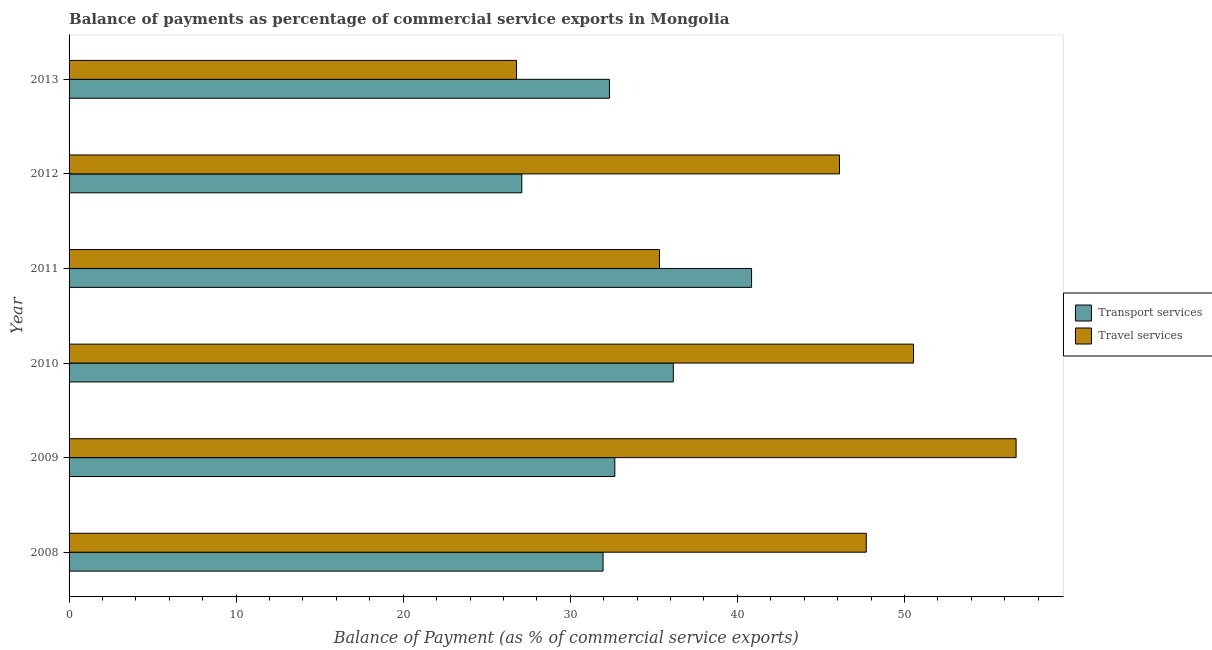Are the number of bars per tick equal to the number of legend labels?
Give a very brief answer. Yes. How many bars are there on the 3rd tick from the top?
Your response must be concise. 2. How many bars are there on the 6th tick from the bottom?
Your answer should be very brief. 2. What is the label of the 3rd group of bars from the top?
Your answer should be very brief. 2011. In how many cases, is the number of bars for a given year not equal to the number of legend labels?
Your answer should be compact. 0. What is the balance of payments of travel services in 2009?
Your answer should be compact. 56.68. Across all years, what is the maximum balance of payments of transport services?
Your answer should be very brief. 40.85. Across all years, what is the minimum balance of payments of travel services?
Make the answer very short. 26.78. In which year was the balance of payments of travel services maximum?
Your answer should be compact. 2009. In which year was the balance of payments of travel services minimum?
Offer a terse response. 2013. What is the total balance of payments of travel services in the graph?
Provide a succinct answer. 263.18. What is the difference between the balance of payments of transport services in 2010 and that in 2013?
Provide a short and direct response. 3.83. What is the difference between the balance of payments of travel services in 2008 and the balance of payments of transport services in 2009?
Give a very brief answer. 15.05. What is the average balance of payments of travel services per year?
Offer a terse response. 43.86. In the year 2012, what is the difference between the balance of payments of travel services and balance of payments of transport services?
Give a very brief answer. 19.02. What is the ratio of the balance of payments of travel services in 2010 to that in 2012?
Offer a very short reply. 1.1. Is the difference between the balance of payments of transport services in 2012 and 2013 greater than the difference between the balance of payments of travel services in 2012 and 2013?
Your answer should be compact. No. What is the difference between the highest and the second highest balance of payments of transport services?
Your answer should be compact. 4.68. What is the difference between the highest and the lowest balance of payments of travel services?
Make the answer very short. 29.9. In how many years, is the balance of payments of travel services greater than the average balance of payments of travel services taken over all years?
Ensure brevity in your answer.  4. What does the 2nd bar from the top in 2011 represents?
Your answer should be compact. Transport services. What does the 2nd bar from the bottom in 2013 represents?
Offer a very short reply. Travel services. Are all the bars in the graph horizontal?
Give a very brief answer. Yes. How many years are there in the graph?
Ensure brevity in your answer.  6. Does the graph contain any zero values?
Offer a very short reply. No. Where does the legend appear in the graph?
Make the answer very short. Center right. What is the title of the graph?
Keep it short and to the point. Balance of payments as percentage of commercial service exports in Mongolia. What is the label or title of the X-axis?
Offer a terse response. Balance of Payment (as % of commercial service exports). What is the Balance of Payment (as % of commercial service exports) in Transport services in 2008?
Provide a succinct answer. 31.96. What is the Balance of Payment (as % of commercial service exports) of Travel services in 2008?
Your answer should be very brief. 47.72. What is the Balance of Payment (as % of commercial service exports) in Transport services in 2009?
Provide a short and direct response. 32.67. What is the Balance of Payment (as % of commercial service exports) in Travel services in 2009?
Your response must be concise. 56.68. What is the Balance of Payment (as % of commercial service exports) of Transport services in 2010?
Your response must be concise. 36.17. What is the Balance of Payment (as % of commercial service exports) of Travel services in 2010?
Make the answer very short. 50.55. What is the Balance of Payment (as % of commercial service exports) in Transport services in 2011?
Ensure brevity in your answer.  40.85. What is the Balance of Payment (as % of commercial service exports) of Travel services in 2011?
Give a very brief answer. 35.34. What is the Balance of Payment (as % of commercial service exports) of Transport services in 2012?
Your answer should be very brief. 27.1. What is the Balance of Payment (as % of commercial service exports) in Travel services in 2012?
Offer a terse response. 46.11. What is the Balance of Payment (as % of commercial service exports) of Transport services in 2013?
Give a very brief answer. 32.34. What is the Balance of Payment (as % of commercial service exports) of Travel services in 2013?
Offer a terse response. 26.78. Across all years, what is the maximum Balance of Payment (as % of commercial service exports) in Transport services?
Provide a succinct answer. 40.85. Across all years, what is the maximum Balance of Payment (as % of commercial service exports) of Travel services?
Keep it short and to the point. 56.68. Across all years, what is the minimum Balance of Payment (as % of commercial service exports) in Transport services?
Your response must be concise. 27.1. Across all years, what is the minimum Balance of Payment (as % of commercial service exports) of Travel services?
Give a very brief answer. 26.78. What is the total Balance of Payment (as % of commercial service exports) of Transport services in the graph?
Ensure brevity in your answer.  201.09. What is the total Balance of Payment (as % of commercial service exports) in Travel services in the graph?
Your response must be concise. 263.18. What is the difference between the Balance of Payment (as % of commercial service exports) in Transport services in 2008 and that in 2009?
Your response must be concise. -0.7. What is the difference between the Balance of Payment (as % of commercial service exports) in Travel services in 2008 and that in 2009?
Make the answer very short. -8.97. What is the difference between the Balance of Payment (as % of commercial service exports) in Transport services in 2008 and that in 2010?
Keep it short and to the point. -4.21. What is the difference between the Balance of Payment (as % of commercial service exports) of Travel services in 2008 and that in 2010?
Offer a terse response. -2.83. What is the difference between the Balance of Payment (as % of commercial service exports) in Transport services in 2008 and that in 2011?
Provide a short and direct response. -8.89. What is the difference between the Balance of Payment (as % of commercial service exports) of Travel services in 2008 and that in 2011?
Provide a short and direct response. 12.38. What is the difference between the Balance of Payment (as % of commercial service exports) in Transport services in 2008 and that in 2012?
Make the answer very short. 4.86. What is the difference between the Balance of Payment (as % of commercial service exports) in Travel services in 2008 and that in 2012?
Make the answer very short. 1.6. What is the difference between the Balance of Payment (as % of commercial service exports) in Transport services in 2008 and that in 2013?
Your answer should be compact. -0.38. What is the difference between the Balance of Payment (as % of commercial service exports) of Travel services in 2008 and that in 2013?
Your answer should be compact. 20.93. What is the difference between the Balance of Payment (as % of commercial service exports) of Transport services in 2009 and that in 2010?
Ensure brevity in your answer.  -3.5. What is the difference between the Balance of Payment (as % of commercial service exports) in Travel services in 2009 and that in 2010?
Keep it short and to the point. 6.14. What is the difference between the Balance of Payment (as % of commercial service exports) of Transport services in 2009 and that in 2011?
Provide a short and direct response. -8.19. What is the difference between the Balance of Payment (as % of commercial service exports) of Travel services in 2009 and that in 2011?
Offer a very short reply. 21.35. What is the difference between the Balance of Payment (as % of commercial service exports) in Transport services in 2009 and that in 2012?
Keep it short and to the point. 5.57. What is the difference between the Balance of Payment (as % of commercial service exports) in Travel services in 2009 and that in 2012?
Your answer should be very brief. 10.57. What is the difference between the Balance of Payment (as % of commercial service exports) in Transport services in 2009 and that in 2013?
Provide a succinct answer. 0.32. What is the difference between the Balance of Payment (as % of commercial service exports) in Travel services in 2009 and that in 2013?
Keep it short and to the point. 29.9. What is the difference between the Balance of Payment (as % of commercial service exports) in Transport services in 2010 and that in 2011?
Offer a very short reply. -4.68. What is the difference between the Balance of Payment (as % of commercial service exports) in Travel services in 2010 and that in 2011?
Provide a short and direct response. 15.21. What is the difference between the Balance of Payment (as % of commercial service exports) in Transport services in 2010 and that in 2012?
Make the answer very short. 9.07. What is the difference between the Balance of Payment (as % of commercial service exports) in Travel services in 2010 and that in 2012?
Provide a succinct answer. 4.43. What is the difference between the Balance of Payment (as % of commercial service exports) in Transport services in 2010 and that in 2013?
Give a very brief answer. 3.83. What is the difference between the Balance of Payment (as % of commercial service exports) of Travel services in 2010 and that in 2013?
Keep it short and to the point. 23.76. What is the difference between the Balance of Payment (as % of commercial service exports) in Transport services in 2011 and that in 2012?
Give a very brief answer. 13.75. What is the difference between the Balance of Payment (as % of commercial service exports) in Travel services in 2011 and that in 2012?
Your response must be concise. -10.78. What is the difference between the Balance of Payment (as % of commercial service exports) in Transport services in 2011 and that in 2013?
Make the answer very short. 8.51. What is the difference between the Balance of Payment (as % of commercial service exports) in Travel services in 2011 and that in 2013?
Offer a terse response. 8.56. What is the difference between the Balance of Payment (as % of commercial service exports) of Transport services in 2012 and that in 2013?
Ensure brevity in your answer.  -5.24. What is the difference between the Balance of Payment (as % of commercial service exports) of Travel services in 2012 and that in 2013?
Make the answer very short. 19.33. What is the difference between the Balance of Payment (as % of commercial service exports) in Transport services in 2008 and the Balance of Payment (as % of commercial service exports) in Travel services in 2009?
Provide a short and direct response. -24.72. What is the difference between the Balance of Payment (as % of commercial service exports) in Transport services in 2008 and the Balance of Payment (as % of commercial service exports) in Travel services in 2010?
Provide a succinct answer. -18.58. What is the difference between the Balance of Payment (as % of commercial service exports) of Transport services in 2008 and the Balance of Payment (as % of commercial service exports) of Travel services in 2011?
Your answer should be very brief. -3.38. What is the difference between the Balance of Payment (as % of commercial service exports) in Transport services in 2008 and the Balance of Payment (as % of commercial service exports) in Travel services in 2012?
Provide a succinct answer. -14.15. What is the difference between the Balance of Payment (as % of commercial service exports) in Transport services in 2008 and the Balance of Payment (as % of commercial service exports) in Travel services in 2013?
Provide a short and direct response. 5.18. What is the difference between the Balance of Payment (as % of commercial service exports) in Transport services in 2009 and the Balance of Payment (as % of commercial service exports) in Travel services in 2010?
Provide a short and direct response. -17.88. What is the difference between the Balance of Payment (as % of commercial service exports) of Transport services in 2009 and the Balance of Payment (as % of commercial service exports) of Travel services in 2011?
Keep it short and to the point. -2.67. What is the difference between the Balance of Payment (as % of commercial service exports) in Transport services in 2009 and the Balance of Payment (as % of commercial service exports) in Travel services in 2012?
Give a very brief answer. -13.45. What is the difference between the Balance of Payment (as % of commercial service exports) in Transport services in 2009 and the Balance of Payment (as % of commercial service exports) in Travel services in 2013?
Make the answer very short. 5.88. What is the difference between the Balance of Payment (as % of commercial service exports) in Transport services in 2010 and the Balance of Payment (as % of commercial service exports) in Travel services in 2011?
Provide a short and direct response. 0.83. What is the difference between the Balance of Payment (as % of commercial service exports) of Transport services in 2010 and the Balance of Payment (as % of commercial service exports) of Travel services in 2012?
Make the answer very short. -9.95. What is the difference between the Balance of Payment (as % of commercial service exports) of Transport services in 2010 and the Balance of Payment (as % of commercial service exports) of Travel services in 2013?
Offer a very short reply. 9.39. What is the difference between the Balance of Payment (as % of commercial service exports) in Transport services in 2011 and the Balance of Payment (as % of commercial service exports) in Travel services in 2012?
Your answer should be compact. -5.26. What is the difference between the Balance of Payment (as % of commercial service exports) of Transport services in 2011 and the Balance of Payment (as % of commercial service exports) of Travel services in 2013?
Make the answer very short. 14.07. What is the difference between the Balance of Payment (as % of commercial service exports) in Transport services in 2012 and the Balance of Payment (as % of commercial service exports) in Travel services in 2013?
Make the answer very short. 0.32. What is the average Balance of Payment (as % of commercial service exports) in Transport services per year?
Your response must be concise. 33.51. What is the average Balance of Payment (as % of commercial service exports) of Travel services per year?
Make the answer very short. 43.86. In the year 2008, what is the difference between the Balance of Payment (as % of commercial service exports) in Transport services and Balance of Payment (as % of commercial service exports) in Travel services?
Your answer should be very brief. -15.75. In the year 2009, what is the difference between the Balance of Payment (as % of commercial service exports) of Transport services and Balance of Payment (as % of commercial service exports) of Travel services?
Your response must be concise. -24.02. In the year 2010, what is the difference between the Balance of Payment (as % of commercial service exports) in Transport services and Balance of Payment (as % of commercial service exports) in Travel services?
Your response must be concise. -14.38. In the year 2011, what is the difference between the Balance of Payment (as % of commercial service exports) in Transport services and Balance of Payment (as % of commercial service exports) in Travel services?
Offer a very short reply. 5.51. In the year 2012, what is the difference between the Balance of Payment (as % of commercial service exports) of Transport services and Balance of Payment (as % of commercial service exports) of Travel services?
Offer a very short reply. -19.01. In the year 2013, what is the difference between the Balance of Payment (as % of commercial service exports) in Transport services and Balance of Payment (as % of commercial service exports) in Travel services?
Make the answer very short. 5.56. What is the ratio of the Balance of Payment (as % of commercial service exports) in Transport services in 2008 to that in 2009?
Give a very brief answer. 0.98. What is the ratio of the Balance of Payment (as % of commercial service exports) in Travel services in 2008 to that in 2009?
Ensure brevity in your answer.  0.84. What is the ratio of the Balance of Payment (as % of commercial service exports) in Transport services in 2008 to that in 2010?
Make the answer very short. 0.88. What is the ratio of the Balance of Payment (as % of commercial service exports) of Travel services in 2008 to that in 2010?
Your answer should be compact. 0.94. What is the ratio of the Balance of Payment (as % of commercial service exports) of Transport services in 2008 to that in 2011?
Your answer should be compact. 0.78. What is the ratio of the Balance of Payment (as % of commercial service exports) of Travel services in 2008 to that in 2011?
Offer a very short reply. 1.35. What is the ratio of the Balance of Payment (as % of commercial service exports) in Transport services in 2008 to that in 2012?
Provide a short and direct response. 1.18. What is the ratio of the Balance of Payment (as % of commercial service exports) in Travel services in 2008 to that in 2012?
Offer a terse response. 1.03. What is the ratio of the Balance of Payment (as % of commercial service exports) of Travel services in 2008 to that in 2013?
Keep it short and to the point. 1.78. What is the ratio of the Balance of Payment (as % of commercial service exports) in Transport services in 2009 to that in 2010?
Provide a short and direct response. 0.9. What is the ratio of the Balance of Payment (as % of commercial service exports) in Travel services in 2009 to that in 2010?
Offer a terse response. 1.12. What is the ratio of the Balance of Payment (as % of commercial service exports) in Transport services in 2009 to that in 2011?
Offer a very short reply. 0.8. What is the ratio of the Balance of Payment (as % of commercial service exports) in Travel services in 2009 to that in 2011?
Provide a short and direct response. 1.6. What is the ratio of the Balance of Payment (as % of commercial service exports) of Transport services in 2009 to that in 2012?
Give a very brief answer. 1.21. What is the ratio of the Balance of Payment (as % of commercial service exports) of Travel services in 2009 to that in 2012?
Ensure brevity in your answer.  1.23. What is the ratio of the Balance of Payment (as % of commercial service exports) in Travel services in 2009 to that in 2013?
Provide a short and direct response. 2.12. What is the ratio of the Balance of Payment (as % of commercial service exports) of Transport services in 2010 to that in 2011?
Your response must be concise. 0.89. What is the ratio of the Balance of Payment (as % of commercial service exports) of Travel services in 2010 to that in 2011?
Make the answer very short. 1.43. What is the ratio of the Balance of Payment (as % of commercial service exports) of Transport services in 2010 to that in 2012?
Offer a very short reply. 1.33. What is the ratio of the Balance of Payment (as % of commercial service exports) in Travel services in 2010 to that in 2012?
Your response must be concise. 1.1. What is the ratio of the Balance of Payment (as % of commercial service exports) in Transport services in 2010 to that in 2013?
Provide a succinct answer. 1.12. What is the ratio of the Balance of Payment (as % of commercial service exports) of Travel services in 2010 to that in 2013?
Provide a succinct answer. 1.89. What is the ratio of the Balance of Payment (as % of commercial service exports) in Transport services in 2011 to that in 2012?
Your response must be concise. 1.51. What is the ratio of the Balance of Payment (as % of commercial service exports) of Travel services in 2011 to that in 2012?
Keep it short and to the point. 0.77. What is the ratio of the Balance of Payment (as % of commercial service exports) of Transport services in 2011 to that in 2013?
Provide a short and direct response. 1.26. What is the ratio of the Balance of Payment (as % of commercial service exports) in Travel services in 2011 to that in 2013?
Offer a very short reply. 1.32. What is the ratio of the Balance of Payment (as % of commercial service exports) in Transport services in 2012 to that in 2013?
Provide a short and direct response. 0.84. What is the ratio of the Balance of Payment (as % of commercial service exports) in Travel services in 2012 to that in 2013?
Keep it short and to the point. 1.72. What is the difference between the highest and the second highest Balance of Payment (as % of commercial service exports) of Transport services?
Your answer should be compact. 4.68. What is the difference between the highest and the second highest Balance of Payment (as % of commercial service exports) in Travel services?
Make the answer very short. 6.14. What is the difference between the highest and the lowest Balance of Payment (as % of commercial service exports) in Transport services?
Offer a very short reply. 13.75. What is the difference between the highest and the lowest Balance of Payment (as % of commercial service exports) of Travel services?
Ensure brevity in your answer.  29.9. 